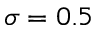<formula> <loc_0><loc_0><loc_500><loc_500>\sigma = 0 . 5</formula> 